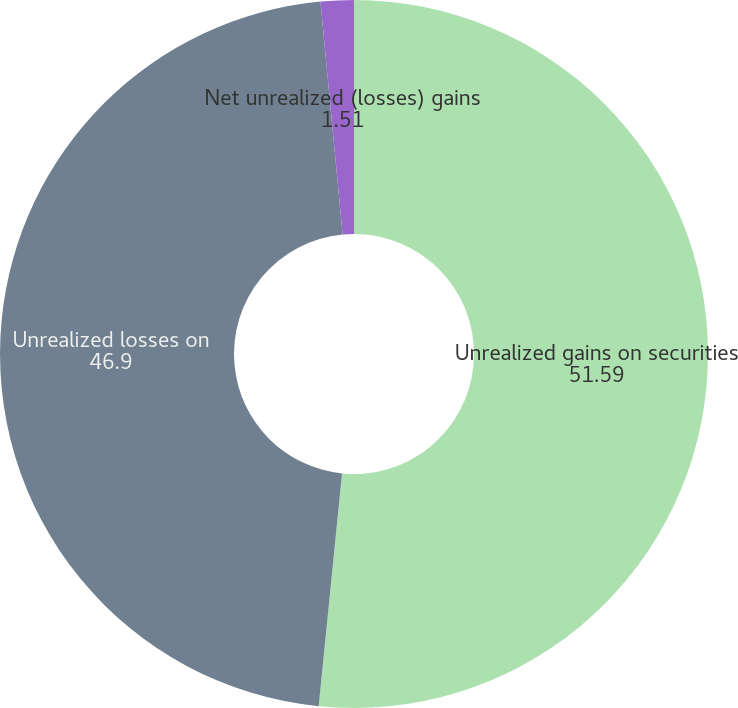Convert chart to OTSL. <chart><loc_0><loc_0><loc_500><loc_500><pie_chart><fcel>Unrealized gains on securities<fcel>Unrealized losses on<fcel>Net unrealized (losses) gains<nl><fcel>51.59%<fcel>46.9%<fcel>1.51%<nl></chart> 